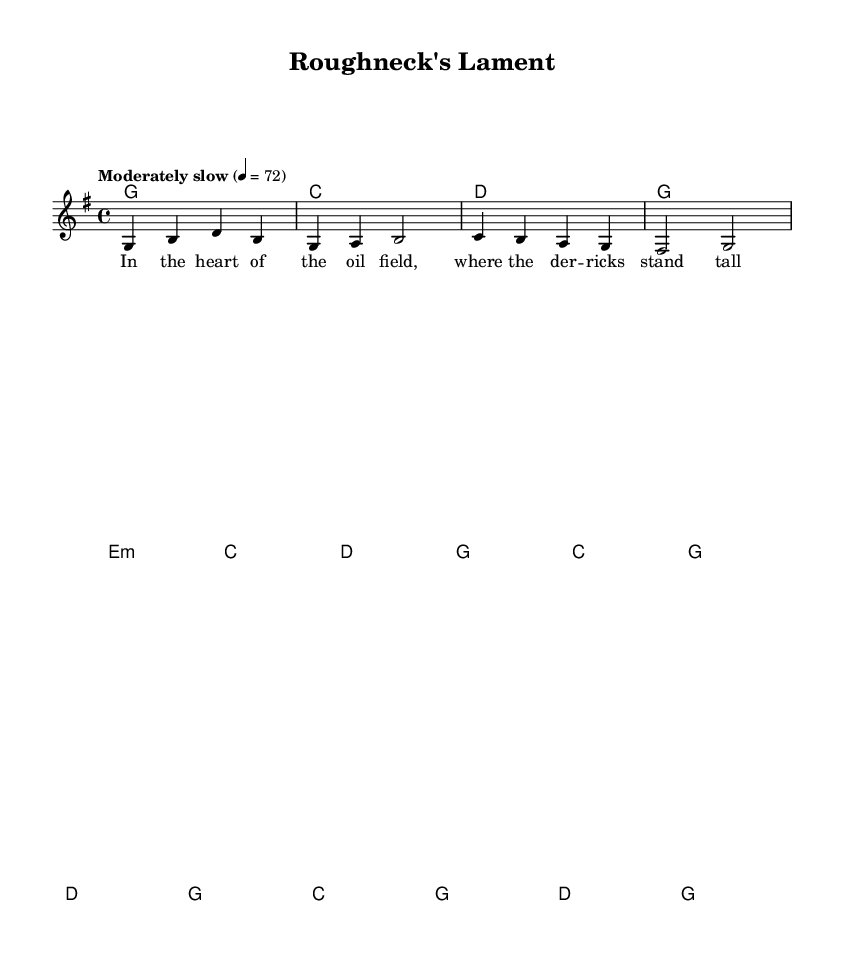What is the key signature of this music? The key signature is G major, which has one sharp (F#). You can identify the key signature at the beginning of the staff where the sharps are indicated.
Answer: G major What is the time signature of this music? The time signature is 4/4, indicated at the beginning of the score. The two numbers signify that there are four beats per measure, and the quarter note is the basic note value.
Answer: 4/4 What is the tempo marking for this piece? The tempo marking is "Moderately slow," specified in the header with a tempo of 4 = 72 beats per minute, suggesting a relaxed pace for the performance.
Answer: Moderately slow How many measures are in the verse? The verse consists of 8 measures, as indicated by the chords and the melody laid out, suggesting a complete cycle of phrases.
Answer: 8 What type of folk theme is represented in the title? The title "Roughneck's Lament" suggests themes related to hardship and sorrow in the lives of oil workers, which is reflective of the folk tradition capturing working-class experiences.
Answer: Hardship What is the first line of the lyrics in the verse? The first line of the lyrics is "In the heart of the oil field, where the der -- ricks stand tall." The lyrics are specified below the melody, and this line sets the scene of the song.
Answer: In the heart of the oil field, where the der -- ricks stand tall Which instrument is primarily used for the melody in this score? The melody is written for vocals, as indicated by the new Voice = "vocals" in the score layout. This suggests that the main musical line will be sung.
Answer: Vocals 